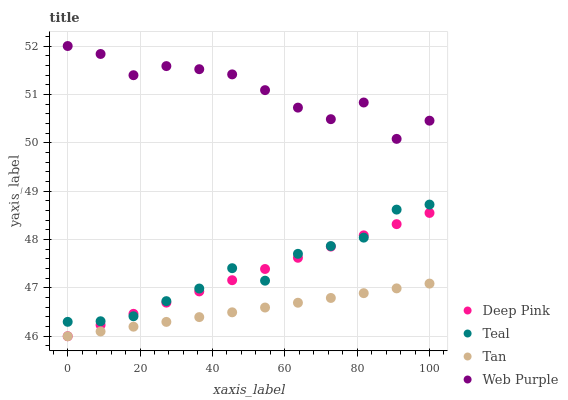Does Tan have the minimum area under the curve?
Answer yes or no. Yes. Does Web Purple have the maximum area under the curve?
Answer yes or no. Yes. Does Deep Pink have the minimum area under the curve?
Answer yes or no. No. Does Deep Pink have the maximum area under the curve?
Answer yes or no. No. Is Deep Pink the smoothest?
Answer yes or no. Yes. Is Web Purple the roughest?
Answer yes or no. Yes. Is Web Purple the smoothest?
Answer yes or no. No. Is Deep Pink the roughest?
Answer yes or no. No. Does Tan have the lowest value?
Answer yes or no. Yes. Does Web Purple have the lowest value?
Answer yes or no. No. Does Web Purple have the highest value?
Answer yes or no. Yes. Does Deep Pink have the highest value?
Answer yes or no. No. Is Deep Pink less than Web Purple?
Answer yes or no. Yes. Is Web Purple greater than Deep Pink?
Answer yes or no. Yes. Does Teal intersect Deep Pink?
Answer yes or no. Yes. Is Teal less than Deep Pink?
Answer yes or no. No. Is Teal greater than Deep Pink?
Answer yes or no. No. Does Deep Pink intersect Web Purple?
Answer yes or no. No. 